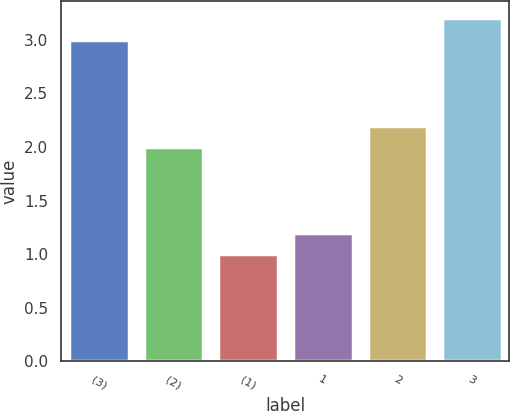Convert chart to OTSL. <chart><loc_0><loc_0><loc_500><loc_500><bar_chart><fcel>(3)<fcel>(2)<fcel>(1)<fcel>1<fcel>2<fcel>3<nl><fcel>3<fcel>2<fcel>1<fcel>1.2<fcel>2.2<fcel>3.2<nl></chart> 